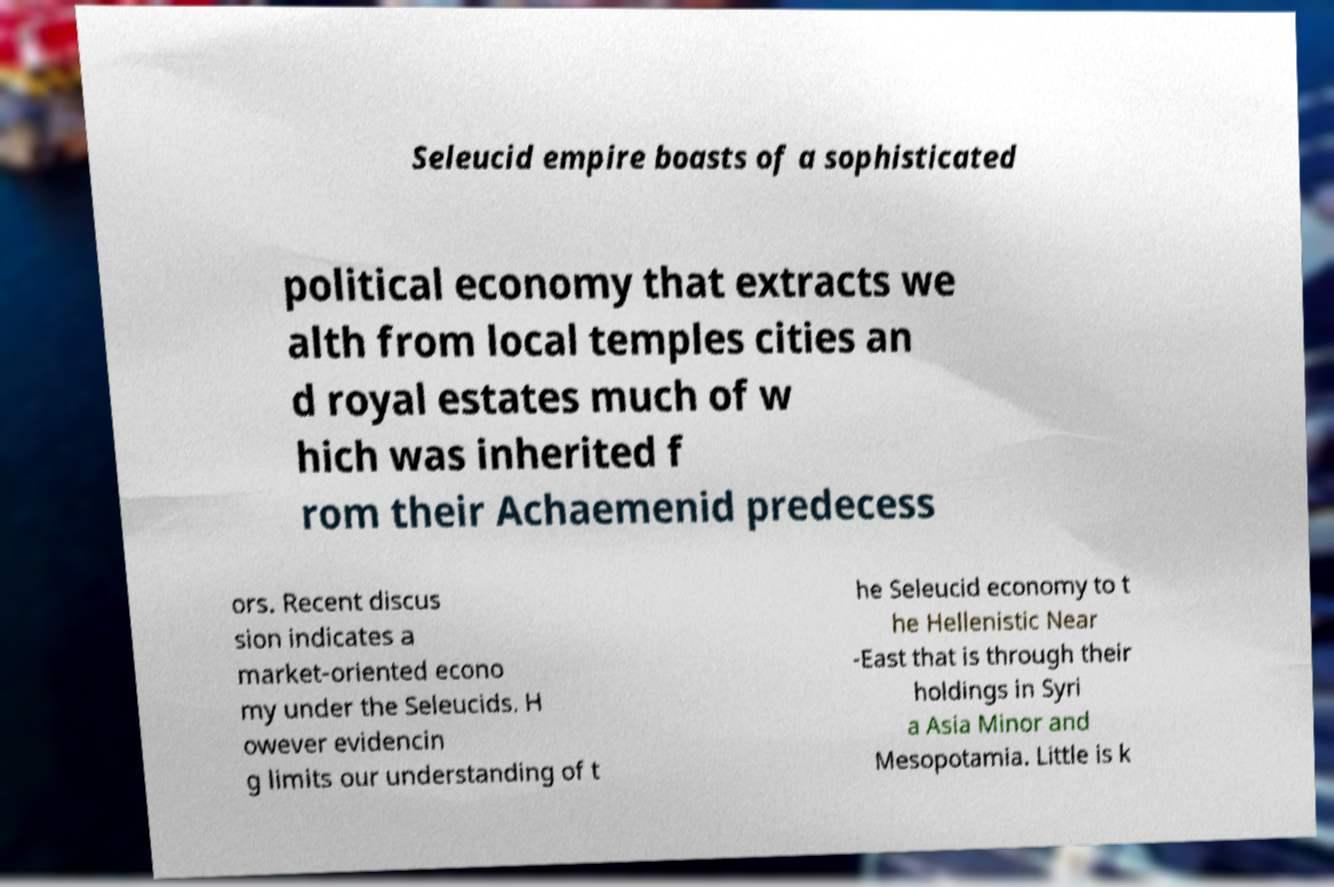Can you accurately transcribe the text from the provided image for me? Seleucid empire boasts of a sophisticated political economy that extracts we alth from local temples cities an d royal estates much of w hich was inherited f rom their Achaemenid predecess ors. Recent discus sion indicates a market-oriented econo my under the Seleucids. H owever evidencin g limits our understanding of t he Seleucid economy to t he Hellenistic Near -East that is through their holdings in Syri a Asia Minor and Mesopotamia. Little is k 